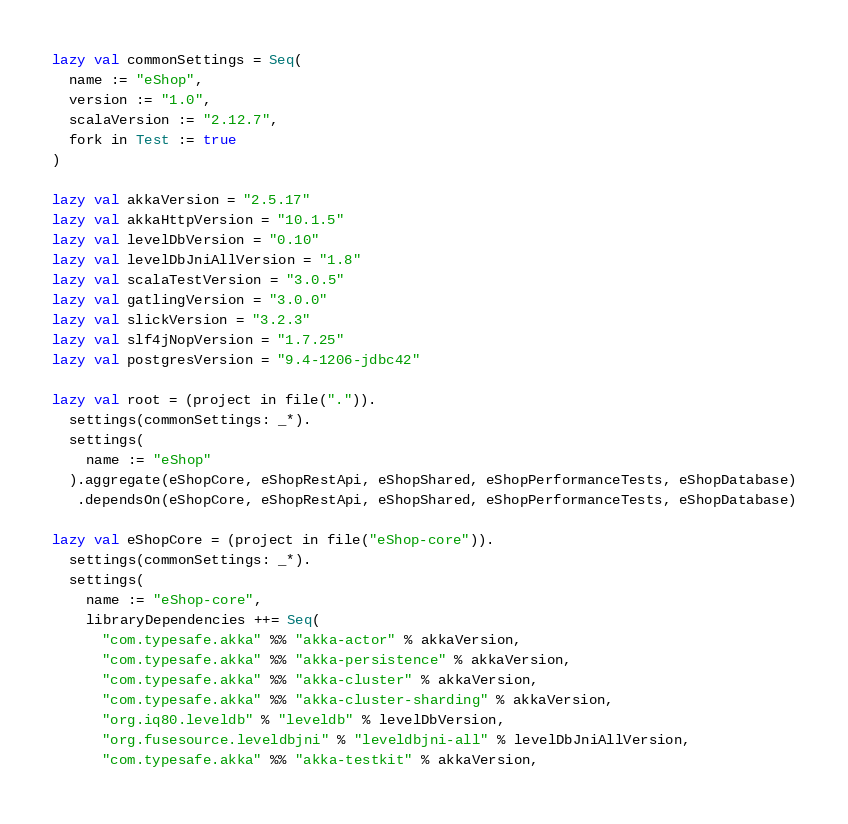Convert code to text. <code><loc_0><loc_0><loc_500><loc_500><_Scala_>lazy val commonSettings = Seq(
  name := "eShop",
  version := "1.0",
  scalaVersion := "2.12.7",
  fork in Test := true
)

lazy val akkaVersion = "2.5.17"
lazy val akkaHttpVersion = "10.1.5"
lazy val levelDbVersion = "0.10"
lazy val levelDbJniAllVersion = "1.8"
lazy val scalaTestVersion = "3.0.5"
lazy val gatlingVersion = "3.0.0"
lazy val slickVersion = "3.2.3"
lazy val slf4jNopVersion = "1.7.25"
lazy val postgresVersion = "9.4-1206-jdbc42"

lazy val root = (project in file(".")).
  settings(commonSettings: _*).
  settings(
    name := "eShop"
  ).aggregate(eShopCore, eShopRestApi, eShopShared, eShopPerformanceTests, eShopDatabase)
   .dependsOn(eShopCore, eShopRestApi, eShopShared, eShopPerformanceTests, eShopDatabase)

lazy val eShopCore = (project in file("eShop-core")).
  settings(commonSettings: _*).
  settings(
    name := "eShop-core",
    libraryDependencies ++= Seq(
      "com.typesafe.akka" %% "akka-actor" % akkaVersion,
      "com.typesafe.akka" %% "akka-persistence" % akkaVersion,
      "com.typesafe.akka" %% "akka-cluster" % akkaVersion,
      "com.typesafe.akka" %% "akka-cluster-sharding" % akkaVersion,
      "org.iq80.leveldb" % "leveldb" % levelDbVersion,
      "org.fusesource.leveldbjni" % "leveldbjni-all" % levelDbJniAllVersion,
      "com.typesafe.akka" %% "akka-testkit" % akkaVersion,</code> 